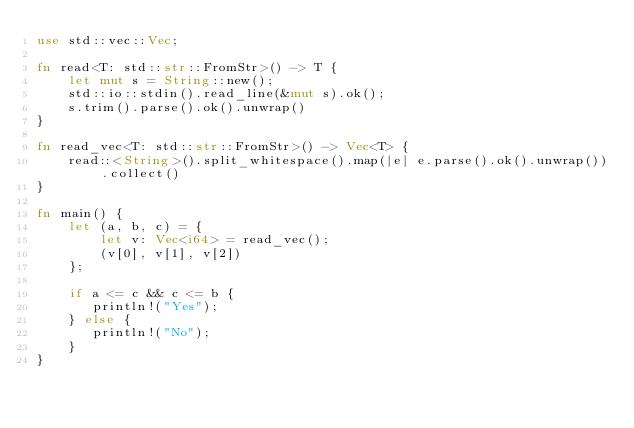<code> <loc_0><loc_0><loc_500><loc_500><_Rust_>use std::vec::Vec;

fn read<T: std::str::FromStr>() -> T {
    let mut s = String::new();
    std::io::stdin().read_line(&mut s).ok();
    s.trim().parse().ok().unwrap()
}

fn read_vec<T: std::str::FromStr>() -> Vec<T> {
    read::<String>().split_whitespace().map(|e| e.parse().ok().unwrap()).collect()
}

fn main() {
    let (a, b, c) = {
        let v: Vec<i64> = read_vec();
        (v[0], v[1], v[2])
    };

    if a <= c && c <= b {
       println!("Yes");
    } else {
       println!("No");
    }
}
</code> 